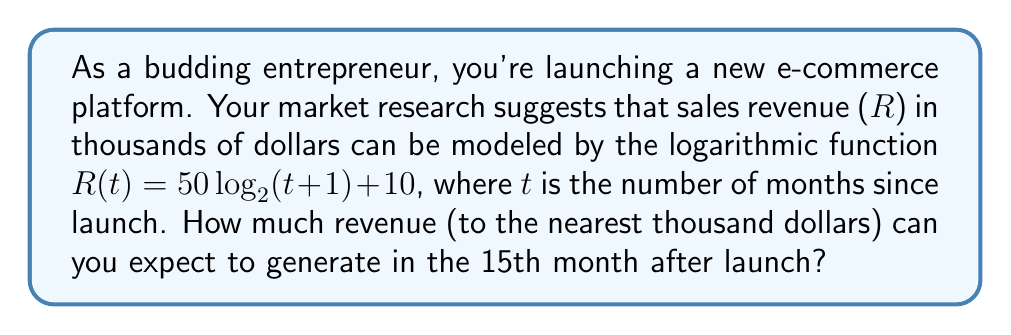Help me with this question. Let's approach this step-by-step:

1) We're given the function $R(t) = 50\log_2(t+1) + 10$, where:
   - R is the revenue in thousands of dollars
   - t is the number of months since launch

2) We need to find R(15), as we're asked about the 15th month:
   $R(15) = 50\log_2(15+1) + 10$

3) Simplify inside the logarithm:
   $R(15) = 50\log_2(16) + 10$

4) Recall that $\log_2(16) = 4$ because $2^4 = 16$:
   $R(15) = 50(4) + 10$

5) Calculate:
   $R(15) = 200 + 10 = 210$

6) Remember, this result is in thousands of dollars. So the actual revenue is $210,000.

7) The question asks for the nearest thousand dollars, so our final answer is $210,000.
Answer: $210,000 